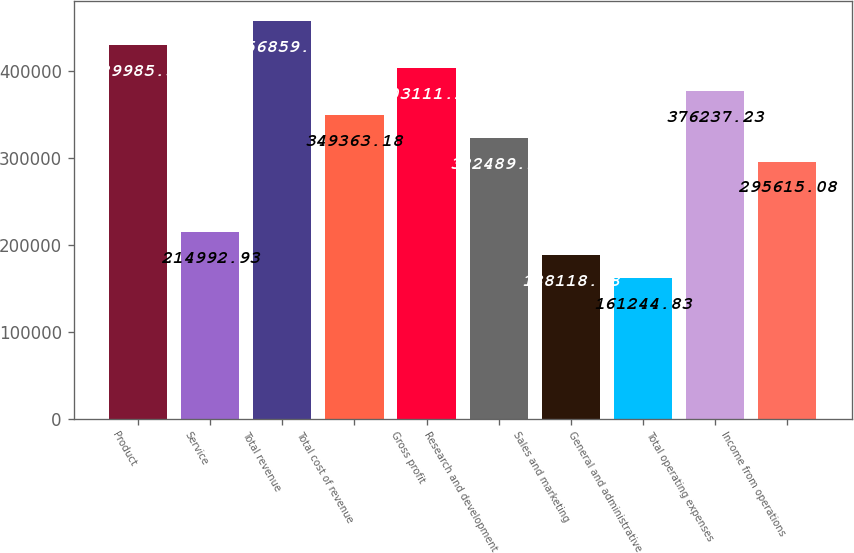Convert chart to OTSL. <chart><loc_0><loc_0><loc_500><loc_500><bar_chart><fcel>Product<fcel>Service<fcel>Total revenue<fcel>Total cost of revenue<fcel>Gross profit<fcel>Research and development<fcel>Sales and marketing<fcel>General and administrative<fcel>Total operating expenses<fcel>Income from operations<nl><fcel>429985<fcel>214993<fcel>456859<fcel>349363<fcel>403111<fcel>322489<fcel>188119<fcel>161245<fcel>376237<fcel>295615<nl></chart> 